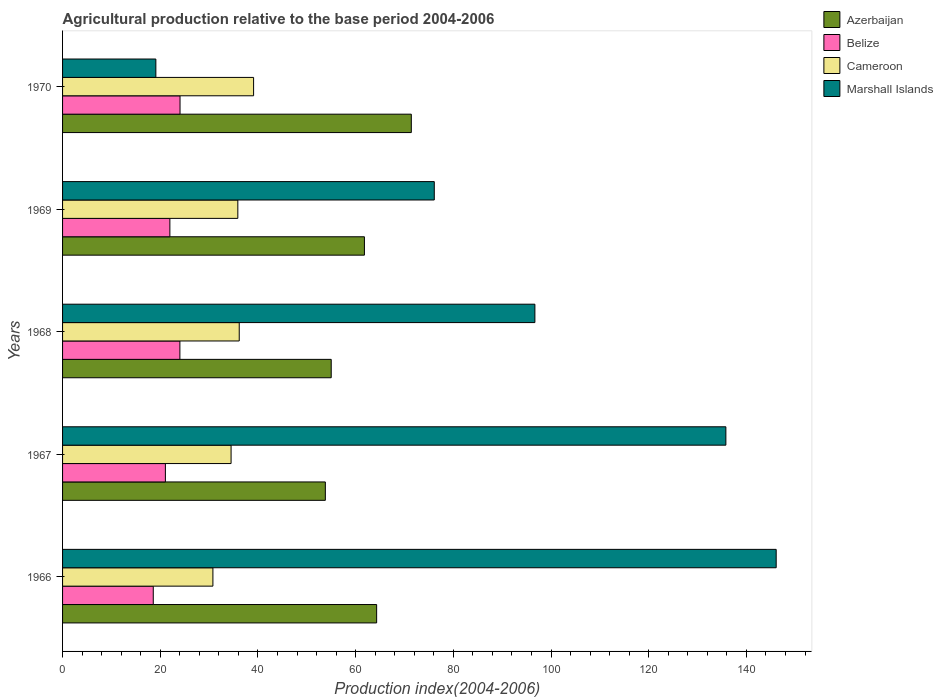How many different coloured bars are there?
Your answer should be compact. 4. Are the number of bars per tick equal to the number of legend labels?
Your answer should be compact. Yes. Are the number of bars on each tick of the Y-axis equal?
Offer a terse response. Yes. What is the label of the 2nd group of bars from the top?
Provide a short and direct response. 1969. What is the agricultural production index in Belize in 1966?
Provide a short and direct response. 18.57. Across all years, what is the maximum agricultural production index in Cameroon?
Keep it short and to the point. 39.11. Across all years, what is the minimum agricultural production index in Azerbaijan?
Offer a terse response. 53.8. In which year was the agricultural production index in Belize maximum?
Your answer should be compact. 1970. In which year was the agricultural production index in Cameroon minimum?
Offer a terse response. 1966. What is the total agricultural production index in Belize in the graph?
Ensure brevity in your answer.  109.66. What is the difference between the agricultural production index in Marshall Islands in 1968 and that in 1969?
Ensure brevity in your answer.  20.6. What is the difference between the agricultural production index in Cameroon in 1969 and the agricultural production index in Marshall Islands in 1968?
Make the answer very short. -60.82. What is the average agricultural production index in Cameroon per year?
Your response must be concise. 35.29. In the year 1967, what is the difference between the agricultural production index in Azerbaijan and agricultural production index in Cameroon?
Keep it short and to the point. 19.3. What is the ratio of the agricultural production index in Cameroon in 1967 to that in 1969?
Ensure brevity in your answer.  0.96. What is the difference between the highest and the second highest agricultural production index in Cameroon?
Offer a very short reply. 2.94. What is the difference between the highest and the lowest agricultural production index in Cameroon?
Provide a succinct answer. 8.33. Is it the case that in every year, the sum of the agricultural production index in Azerbaijan and agricultural production index in Marshall Islands is greater than the sum of agricultural production index in Cameroon and agricultural production index in Belize?
Make the answer very short. Yes. What does the 2nd bar from the top in 1968 represents?
Keep it short and to the point. Cameroon. What does the 4th bar from the bottom in 1966 represents?
Give a very brief answer. Marshall Islands. How many years are there in the graph?
Your response must be concise. 5. What is the difference between two consecutive major ticks on the X-axis?
Your response must be concise. 20. Are the values on the major ticks of X-axis written in scientific E-notation?
Keep it short and to the point. No. How are the legend labels stacked?
Offer a very short reply. Vertical. What is the title of the graph?
Offer a terse response. Agricultural production relative to the base period 2004-2006. What is the label or title of the X-axis?
Provide a short and direct response. Production index(2004-2006). What is the label or title of the Y-axis?
Make the answer very short. Years. What is the Production index(2004-2006) of Azerbaijan in 1966?
Your answer should be very brief. 64.3. What is the Production index(2004-2006) in Belize in 1966?
Your answer should be compact. 18.57. What is the Production index(2004-2006) in Cameroon in 1966?
Your answer should be compact. 30.78. What is the Production index(2004-2006) of Marshall Islands in 1966?
Make the answer very short. 146.1. What is the Production index(2004-2006) of Azerbaijan in 1967?
Keep it short and to the point. 53.8. What is the Production index(2004-2006) of Belize in 1967?
Your answer should be compact. 21.05. What is the Production index(2004-2006) of Cameroon in 1967?
Your answer should be compact. 34.5. What is the Production index(2004-2006) in Marshall Islands in 1967?
Give a very brief answer. 135.8. What is the Production index(2004-2006) in Belize in 1968?
Your answer should be very brief. 24.02. What is the Production index(2004-2006) in Cameroon in 1968?
Offer a very short reply. 36.17. What is the Production index(2004-2006) of Marshall Islands in 1968?
Give a very brief answer. 96.7. What is the Production index(2004-2006) in Azerbaijan in 1969?
Offer a terse response. 61.8. What is the Production index(2004-2006) in Belize in 1969?
Give a very brief answer. 21.97. What is the Production index(2004-2006) of Cameroon in 1969?
Keep it short and to the point. 35.88. What is the Production index(2004-2006) in Marshall Islands in 1969?
Make the answer very short. 76.1. What is the Production index(2004-2006) of Azerbaijan in 1970?
Provide a succinct answer. 71.4. What is the Production index(2004-2006) in Belize in 1970?
Your answer should be compact. 24.05. What is the Production index(2004-2006) of Cameroon in 1970?
Provide a short and direct response. 39.11. What is the Production index(2004-2006) of Marshall Islands in 1970?
Offer a very short reply. 19.1. Across all years, what is the maximum Production index(2004-2006) in Azerbaijan?
Ensure brevity in your answer.  71.4. Across all years, what is the maximum Production index(2004-2006) in Belize?
Provide a succinct answer. 24.05. Across all years, what is the maximum Production index(2004-2006) in Cameroon?
Keep it short and to the point. 39.11. Across all years, what is the maximum Production index(2004-2006) of Marshall Islands?
Keep it short and to the point. 146.1. Across all years, what is the minimum Production index(2004-2006) of Azerbaijan?
Offer a very short reply. 53.8. Across all years, what is the minimum Production index(2004-2006) in Belize?
Make the answer very short. 18.57. Across all years, what is the minimum Production index(2004-2006) in Cameroon?
Provide a succinct answer. 30.78. What is the total Production index(2004-2006) of Azerbaijan in the graph?
Your answer should be very brief. 306.3. What is the total Production index(2004-2006) of Belize in the graph?
Keep it short and to the point. 109.66. What is the total Production index(2004-2006) of Cameroon in the graph?
Offer a very short reply. 176.44. What is the total Production index(2004-2006) of Marshall Islands in the graph?
Make the answer very short. 473.8. What is the difference between the Production index(2004-2006) of Belize in 1966 and that in 1967?
Provide a succinct answer. -2.48. What is the difference between the Production index(2004-2006) in Cameroon in 1966 and that in 1967?
Give a very brief answer. -3.72. What is the difference between the Production index(2004-2006) in Azerbaijan in 1966 and that in 1968?
Your response must be concise. 9.3. What is the difference between the Production index(2004-2006) of Belize in 1966 and that in 1968?
Give a very brief answer. -5.45. What is the difference between the Production index(2004-2006) of Cameroon in 1966 and that in 1968?
Offer a terse response. -5.39. What is the difference between the Production index(2004-2006) in Marshall Islands in 1966 and that in 1968?
Provide a short and direct response. 49.4. What is the difference between the Production index(2004-2006) in Azerbaijan in 1966 and that in 1969?
Make the answer very short. 2.5. What is the difference between the Production index(2004-2006) of Marshall Islands in 1966 and that in 1969?
Your answer should be compact. 70. What is the difference between the Production index(2004-2006) of Belize in 1966 and that in 1970?
Ensure brevity in your answer.  -5.48. What is the difference between the Production index(2004-2006) in Cameroon in 1966 and that in 1970?
Offer a very short reply. -8.33. What is the difference between the Production index(2004-2006) in Marshall Islands in 1966 and that in 1970?
Offer a very short reply. 127. What is the difference between the Production index(2004-2006) in Belize in 1967 and that in 1968?
Your response must be concise. -2.97. What is the difference between the Production index(2004-2006) of Cameroon in 1967 and that in 1968?
Offer a terse response. -1.67. What is the difference between the Production index(2004-2006) of Marshall Islands in 1967 and that in 1968?
Ensure brevity in your answer.  39.1. What is the difference between the Production index(2004-2006) in Azerbaijan in 1967 and that in 1969?
Your response must be concise. -8. What is the difference between the Production index(2004-2006) in Belize in 1967 and that in 1969?
Ensure brevity in your answer.  -0.92. What is the difference between the Production index(2004-2006) of Cameroon in 1967 and that in 1969?
Your answer should be compact. -1.38. What is the difference between the Production index(2004-2006) of Marshall Islands in 1967 and that in 1969?
Your answer should be compact. 59.7. What is the difference between the Production index(2004-2006) of Azerbaijan in 1967 and that in 1970?
Make the answer very short. -17.6. What is the difference between the Production index(2004-2006) in Cameroon in 1967 and that in 1970?
Provide a succinct answer. -4.61. What is the difference between the Production index(2004-2006) of Marshall Islands in 1967 and that in 1970?
Make the answer very short. 116.7. What is the difference between the Production index(2004-2006) of Belize in 1968 and that in 1969?
Your response must be concise. 2.05. What is the difference between the Production index(2004-2006) of Cameroon in 1968 and that in 1969?
Provide a short and direct response. 0.29. What is the difference between the Production index(2004-2006) of Marshall Islands in 1968 and that in 1969?
Provide a short and direct response. 20.6. What is the difference between the Production index(2004-2006) of Azerbaijan in 1968 and that in 1970?
Offer a very short reply. -16.4. What is the difference between the Production index(2004-2006) of Belize in 1968 and that in 1970?
Your answer should be very brief. -0.03. What is the difference between the Production index(2004-2006) of Cameroon in 1968 and that in 1970?
Offer a very short reply. -2.94. What is the difference between the Production index(2004-2006) of Marshall Islands in 1968 and that in 1970?
Give a very brief answer. 77.6. What is the difference between the Production index(2004-2006) in Azerbaijan in 1969 and that in 1970?
Your answer should be compact. -9.6. What is the difference between the Production index(2004-2006) of Belize in 1969 and that in 1970?
Keep it short and to the point. -2.08. What is the difference between the Production index(2004-2006) of Cameroon in 1969 and that in 1970?
Your answer should be compact. -3.23. What is the difference between the Production index(2004-2006) in Azerbaijan in 1966 and the Production index(2004-2006) in Belize in 1967?
Your answer should be very brief. 43.25. What is the difference between the Production index(2004-2006) of Azerbaijan in 1966 and the Production index(2004-2006) of Cameroon in 1967?
Make the answer very short. 29.8. What is the difference between the Production index(2004-2006) of Azerbaijan in 1966 and the Production index(2004-2006) of Marshall Islands in 1967?
Provide a succinct answer. -71.5. What is the difference between the Production index(2004-2006) in Belize in 1966 and the Production index(2004-2006) in Cameroon in 1967?
Keep it short and to the point. -15.93. What is the difference between the Production index(2004-2006) in Belize in 1966 and the Production index(2004-2006) in Marshall Islands in 1967?
Give a very brief answer. -117.23. What is the difference between the Production index(2004-2006) of Cameroon in 1966 and the Production index(2004-2006) of Marshall Islands in 1967?
Your answer should be compact. -105.02. What is the difference between the Production index(2004-2006) in Azerbaijan in 1966 and the Production index(2004-2006) in Belize in 1968?
Give a very brief answer. 40.28. What is the difference between the Production index(2004-2006) in Azerbaijan in 1966 and the Production index(2004-2006) in Cameroon in 1968?
Your response must be concise. 28.13. What is the difference between the Production index(2004-2006) of Azerbaijan in 1966 and the Production index(2004-2006) of Marshall Islands in 1968?
Make the answer very short. -32.4. What is the difference between the Production index(2004-2006) of Belize in 1966 and the Production index(2004-2006) of Cameroon in 1968?
Your answer should be compact. -17.6. What is the difference between the Production index(2004-2006) of Belize in 1966 and the Production index(2004-2006) of Marshall Islands in 1968?
Keep it short and to the point. -78.13. What is the difference between the Production index(2004-2006) in Cameroon in 1966 and the Production index(2004-2006) in Marshall Islands in 1968?
Offer a terse response. -65.92. What is the difference between the Production index(2004-2006) of Azerbaijan in 1966 and the Production index(2004-2006) of Belize in 1969?
Offer a terse response. 42.33. What is the difference between the Production index(2004-2006) of Azerbaijan in 1966 and the Production index(2004-2006) of Cameroon in 1969?
Make the answer very short. 28.42. What is the difference between the Production index(2004-2006) in Azerbaijan in 1966 and the Production index(2004-2006) in Marshall Islands in 1969?
Keep it short and to the point. -11.8. What is the difference between the Production index(2004-2006) of Belize in 1966 and the Production index(2004-2006) of Cameroon in 1969?
Your answer should be compact. -17.31. What is the difference between the Production index(2004-2006) in Belize in 1966 and the Production index(2004-2006) in Marshall Islands in 1969?
Offer a terse response. -57.53. What is the difference between the Production index(2004-2006) of Cameroon in 1966 and the Production index(2004-2006) of Marshall Islands in 1969?
Give a very brief answer. -45.32. What is the difference between the Production index(2004-2006) in Azerbaijan in 1966 and the Production index(2004-2006) in Belize in 1970?
Provide a short and direct response. 40.25. What is the difference between the Production index(2004-2006) of Azerbaijan in 1966 and the Production index(2004-2006) of Cameroon in 1970?
Give a very brief answer. 25.19. What is the difference between the Production index(2004-2006) in Azerbaijan in 1966 and the Production index(2004-2006) in Marshall Islands in 1970?
Ensure brevity in your answer.  45.2. What is the difference between the Production index(2004-2006) in Belize in 1966 and the Production index(2004-2006) in Cameroon in 1970?
Keep it short and to the point. -20.54. What is the difference between the Production index(2004-2006) of Belize in 1966 and the Production index(2004-2006) of Marshall Islands in 1970?
Give a very brief answer. -0.53. What is the difference between the Production index(2004-2006) in Cameroon in 1966 and the Production index(2004-2006) in Marshall Islands in 1970?
Ensure brevity in your answer.  11.68. What is the difference between the Production index(2004-2006) in Azerbaijan in 1967 and the Production index(2004-2006) in Belize in 1968?
Ensure brevity in your answer.  29.78. What is the difference between the Production index(2004-2006) of Azerbaijan in 1967 and the Production index(2004-2006) of Cameroon in 1968?
Your answer should be compact. 17.63. What is the difference between the Production index(2004-2006) in Azerbaijan in 1967 and the Production index(2004-2006) in Marshall Islands in 1968?
Your response must be concise. -42.9. What is the difference between the Production index(2004-2006) of Belize in 1967 and the Production index(2004-2006) of Cameroon in 1968?
Provide a succinct answer. -15.12. What is the difference between the Production index(2004-2006) in Belize in 1967 and the Production index(2004-2006) in Marshall Islands in 1968?
Provide a succinct answer. -75.65. What is the difference between the Production index(2004-2006) in Cameroon in 1967 and the Production index(2004-2006) in Marshall Islands in 1968?
Offer a very short reply. -62.2. What is the difference between the Production index(2004-2006) of Azerbaijan in 1967 and the Production index(2004-2006) of Belize in 1969?
Your answer should be compact. 31.83. What is the difference between the Production index(2004-2006) in Azerbaijan in 1967 and the Production index(2004-2006) in Cameroon in 1969?
Make the answer very short. 17.92. What is the difference between the Production index(2004-2006) in Azerbaijan in 1967 and the Production index(2004-2006) in Marshall Islands in 1969?
Offer a very short reply. -22.3. What is the difference between the Production index(2004-2006) of Belize in 1967 and the Production index(2004-2006) of Cameroon in 1969?
Your response must be concise. -14.83. What is the difference between the Production index(2004-2006) in Belize in 1967 and the Production index(2004-2006) in Marshall Islands in 1969?
Your answer should be very brief. -55.05. What is the difference between the Production index(2004-2006) of Cameroon in 1967 and the Production index(2004-2006) of Marshall Islands in 1969?
Provide a short and direct response. -41.6. What is the difference between the Production index(2004-2006) of Azerbaijan in 1967 and the Production index(2004-2006) of Belize in 1970?
Your answer should be compact. 29.75. What is the difference between the Production index(2004-2006) in Azerbaijan in 1967 and the Production index(2004-2006) in Cameroon in 1970?
Provide a short and direct response. 14.69. What is the difference between the Production index(2004-2006) of Azerbaijan in 1967 and the Production index(2004-2006) of Marshall Islands in 1970?
Provide a succinct answer. 34.7. What is the difference between the Production index(2004-2006) in Belize in 1967 and the Production index(2004-2006) in Cameroon in 1970?
Offer a very short reply. -18.06. What is the difference between the Production index(2004-2006) in Belize in 1967 and the Production index(2004-2006) in Marshall Islands in 1970?
Provide a succinct answer. 1.95. What is the difference between the Production index(2004-2006) in Cameroon in 1967 and the Production index(2004-2006) in Marshall Islands in 1970?
Keep it short and to the point. 15.4. What is the difference between the Production index(2004-2006) of Azerbaijan in 1968 and the Production index(2004-2006) of Belize in 1969?
Make the answer very short. 33.03. What is the difference between the Production index(2004-2006) in Azerbaijan in 1968 and the Production index(2004-2006) in Cameroon in 1969?
Provide a succinct answer. 19.12. What is the difference between the Production index(2004-2006) of Azerbaijan in 1968 and the Production index(2004-2006) of Marshall Islands in 1969?
Provide a short and direct response. -21.1. What is the difference between the Production index(2004-2006) in Belize in 1968 and the Production index(2004-2006) in Cameroon in 1969?
Ensure brevity in your answer.  -11.86. What is the difference between the Production index(2004-2006) in Belize in 1968 and the Production index(2004-2006) in Marshall Islands in 1969?
Ensure brevity in your answer.  -52.08. What is the difference between the Production index(2004-2006) of Cameroon in 1968 and the Production index(2004-2006) of Marshall Islands in 1969?
Your answer should be compact. -39.93. What is the difference between the Production index(2004-2006) in Azerbaijan in 1968 and the Production index(2004-2006) in Belize in 1970?
Make the answer very short. 30.95. What is the difference between the Production index(2004-2006) of Azerbaijan in 1968 and the Production index(2004-2006) of Cameroon in 1970?
Your answer should be compact. 15.89. What is the difference between the Production index(2004-2006) in Azerbaijan in 1968 and the Production index(2004-2006) in Marshall Islands in 1970?
Keep it short and to the point. 35.9. What is the difference between the Production index(2004-2006) of Belize in 1968 and the Production index(2004-2006) of Cameroon in 1970?
Offer a very short reply. -15.09. What is the difference between the Production index(2004-2006) in Belize in 1968 and the Production index(2004-2006) in Marshall Islands in 1970?
Provide a succinct answer. 4.92. What is the difference between the Production index(2004-2006) in Cameroon in 1968 and the Production index(2004-2006) in Marshall Islands in 1970?
Offer a terse response. 17.07. What is the difference between the Production index(2004-2006) of Azerbaijan in 1969 and the Production index(2004-2006) of Belize in 1970?
Ensure brevity in your answer.  37.75. What is the difference between the Production index(2004-2006) in Azerbaijan in 1969 and the Production index(2004-2006) in Cameroon in 1970?
Offer a very short reply. 22.69. What is the difference between the Production index(2004-2006) of Azerbaijan in 1969 and the Production index(2004-2006) of Marshall Islands in 1970?
Keep it short and to the point. 42.7. What is the difference between the Production index(2004-2006) in Belize in 1969 and the Production index(2004-2006) in Cameroon in 1970?
Offer a very short reply. -17.14. What is the difference between the Production index(2004-2006) in Belize in 1969 and the Production index(2004-2006) in Marshall Islands in 1970?
Keep it short and to the point. 2.87. What is the difference between the Production index(2004-2006) of Cameroon in 1969 and the Production index(2004-2006) of Marshall Islands in 1970?
Offer a terse response. 16.78. What is the average Production index(2004-2006) of Azerbaijan per year?
Offer a terse response. 61.26. What is the average Production index(2004-2006) of Belize per year?
Your answer should be compact. 21.93. What is the average Production index(2004-2006) in Cameroon per year?
Give a very brief answer. 35.29. What is the average Production index(2004-2006) in Marshall Islands per year?
Your answer should be compact. 94.76. In the year 1966, what is the difference between the Production index(2004-2006) in Azerbaijan and Production index(2004-2006) in Belize?
Provide a succinct answer. 45.73. In the year 1966, what is the difference between the Production index(2004-2006) of Azerbaijan and Production index(2004-2006) of Cameroon?
Offer a terse response. 33.52. In the year 1966, what is the difference between the Production index(2004-2006) in Azerbaijan and Production index(2004-2006) in Marshall Islands?
Provide a short and direct response. -81.8. In the year 1966, what is the difference between the Production index(2004-2006) of Belize and Production index(2004-2006) of Cameroon?
Give a very brief answer. -12.21. In the year 1966, what is the difference between the Production index(2004-2006) in Belize and Production index(2004-2006) in Marshall Islands?
Ensure brevity in your answer.  -127.53. In the year 1966, what is the difference between the Production index(2004-2006) in Cameroon and Production index(2004-2006) in Marshall Islands?
Your response must be concise. -115.32. In the year 1967, what is the difference between the Production index(2004-2006) of Azerbaijan and Production index(2004-2006) of Belize?
Make the answer very short. 32.75. In the year 1967, what is the difference between the Production index(2004-2006) in Azerbaijan and Production index(2004-2006) in Cameroon?
Provide a succinct answer. 19.3. In the year 1967, what is the difference between the Production index(2004-2006) in Azerbaijan and Production index(2004-2006) in Marshall Islands?
Give a very brief answer. -82. In the year 1967, what is the difference between the Production index(2004-2006) of Belize and Production index(2004-2006) of Cameroon?
Ensure brevity in your answer.  -13.45. In the year 1967, what is the difference between the Production index(2004-2006) in Belize and Production index(2004-2006) in Marshall Islands?
Offer a terse response. -114.75. In the year 1967, what is the difference between the Production index(2004-2006) of Cameroon and Production index(2004-2006) of Marshall Islands?
Give a very brief answer. -101.3. In the year 1968, what is the difference between the Production index(2004-2006) in Azerbaijan and Production index(2004-2006) in Belize?
Your response must be concise. 30.98. In the year 1968, what is the difference between the Production index(2004-2006) in Azerbaijan and Production index(2004-2006) in Cameroon?
Provide a short and direct response. 18.83. In the year 1968, what is the difference between the Production index(2004-2006) in Azerbaijan and Production index(2004-2006) in Marshall Islands?
Give a very brief answer. -41.7. In the year 1968, what is the difference between the Production index(2004-2006) in Belize and Production index(2004-2006) in Cameroon?
Keep it short and to the point. -12.15. In the year 1968, what is the difference between the Production index(2004-2006) in Belize and Production index(2004-2006) in Marshall Islands?
Offer a very short reply. -72.68. In the year 1968, what is the difference between the Production index(2004-2006) of Cameroon and Production index(2004-2006) of Marshall Islands?
Your answer should be compact. -60.53. In the year 1969, what is the difference between the Production index(2004-2006) in Azerbaijan and Production index(2004-2006) in Belize?
Offer a terse response. 39.83. In the year 1969, what is the difference between the Production index(2004-2006) in Azerbaijan and Production index(2004-2006) in Cameroon?
Offer a terse response. 25.92. In the year 1969, what is the difference between the Production index(2004-2006) of Azerbaijan and Production index(2004-2006) of Marshall Islands?
Provide a short and direct response. -14.3. In the year 1969, what is the difference between the Production index(2004-2006) of Belize and Production index(2004-2006) of Cameroon?
Your answer should be compact. -13.91. In the year 1969, what is the difference between the Production index(2004-2006) of Belize and Production index(2004-2006) of Marshall Islands?
Provide a succinct answer. -54.13. In the year 1969, what is the difference between the Production index(2004-2006) in Cameroon and Production index(2004-2006) in Marshall Islands?
Make the answer very short. -40.22. In the year 1970, what is the difference between the Production index(2004-2006) in Azerbaijan and Production index(2004-2006) in Belize?
Your answer should be compact. 47.35. In the year 1970, what is the difference between the Production index(2004-2006) in Azerbaijan and Production index(2004-2006) in Cameroon?
Provide a succinct answer. 32.29. In the year 1970, what is the difference between the Production index(2004-2006) in Azerbaijan and Production index(2004-2006) in Marshall Islands?
Give a very brief answer. 52.3. In the year 1970, what is the difference between the Production index(2004-2006) in Belize and Production index(2004-2006) in Cameroon?
Provide a succinct answer. -15.06. In the year 1970, what is the difference between the Production index(2004-2006) of Belize and Production index(2004-2006) of Marshall Islands?
Your answer should be compact. 4.95. In the year 1970, what is the difference between the Production index(2004-2006) in Cameroon and Production index(2004-2006) in Marshall Islands?
Offer a terse response. 20.01. What is the ratio of the Production index(2004-2006) of Azerbaijan in 1966 to that in 1967?
Provide a succinct answer. 1.2. What is the ratio of the Production index(2004-2006) in Belize in 1966 to that in 1967?
Your response must be concise. 0.88. What is the ratio of the Production index(2004-2006) of Cameroon in 1966 to that in 1967?
Your response must be concise. 0.89. What is the ratio of the Production index(2004-2006) in Marshall Islands in 1966 to that in 1967?
Ensure brevity in your answer.  1.08. What is the ratio of the Production index(2004-2006) of Azerbaijan in 1966 to that in 1968?
Provide a short and direct response. 1.17. What is the ratio of the Production index(2004-2006) of Belize in 1966 to that in 1968?
Give a very brief answer. 0.77. What is the ratio of the Production index(2004-2006) in Cameroon in 1966 to that in 1968?
Ensure brevity in your answer.  0.85. What is the ratio of the Production index(2004-2006) of Marshall Islands in 1966 to that in 1968?
Your answer should be compact. 1.51. What is the ratio of the Production index(2004-2006) of Azerbaijan in 1966 to that in 1969?
Your answer should be compact. 1.04. What is the ratio of the Production index(2004-2006) in Belize in 1966 to that in 1969?
Provide a succinct answer. 0.85. What is the ratio of the Production index(2004-2006) of Cameroon in 1966 to that in 1969?
Your answer should be very brief. 0.86. What is the ratio of the Production index(2004-2006) in Marshall Islands in 1966 to that in 1969?
Offer a terse response. 1.92. What is the ratio of the Production index(2004-2006) in Azerbaijan in 1966 to that in 1970?
Give a very brief answer. 0.9. What is the ratio of the Production index(2004-2006) of Belize in 1966 to that in 1970?
Offer a terse response. 0.77. What is the ratio of the Production index(2004-2006) of Cameroon in 1966 to that in 1970?
Provide a short and direct response. 0.79. What is the ratio of the Production index(2004-2006) in Marshall Islands in 1966 to that in 1970?
Keep it short and to the point. 7.65. What is the ratio of the Production index(2004-2006) in Azerbaijan in 1967 to that in 1968?
Provide a succinct answer. 0.98. What is the ratio of the Production index(2004-2006) of Belize in 1967 to that in 1968?
Provide a short and direct response. 0.88. What is the ratio of the Production index(2004-2006) in Cameroon in 1967 to that in 1968?
Make the answer very short. 0.95. What is the ratio of the Production index(2004-2006) in Marshall Islands in 1967 to that in 1968?
Your response must be concise. 1.4. What is the ratio of the Production index(2004-2006) in Azerbaijan in 1967 to that in 1969?
Offer a terse response. 0.87. What is the ratio of the Production index(2004-2006) of Belize in 1967 to that in 1969?
Your response must be concise. 0.96. What is the ratio of the Production index(2004-2006) of Cameroon in 1967 to that in 1969?
Provide a succinct answer. 0.96. What is the ratio of the Production index(2004-2006) in Marshall Islands in 1967 to that in 1969?
Your response must be concise. 1.78. What is the ratio of the Production index(2004-2006) of Azerbaijan in 1967 to that in 1970?
Your answer should be very brief. 0.75. What is the ratio of the Production index(2004-2006) of Belize in 1967 to that in 1970?
Keep it short and to the point. 0.88. What is the ratio of the Production index(2004-2006) in Cameroon in 1967 to that in 1970?
Your answer should be very brief. 0.88. What is the ratio of the Production index(2004-2006) in Marshall Islands in 1967 to that in 1970?
Your answer should be very brief. 7.11. What is the ratio of the Production index(2004-2006) in Azerbaijan in 1968 to that in 1969?
Offer a terse response. 0.89. What is the ratio of the Production index(2004-2006) in Belize in 1968 to that in 1969?
Ensure brevity in your answer.  1.09. What is the ratio of the Production index(2004-2006) in Marshall Islands in 1968 to that in 1969?
Ensure brevity in your answer.  1.27. What is the ratio of the Production index(2004-2006) of Azerbaijan in 1968 to that in 1970?
Make the answer very short. 0.77. What is the ratio of the Production index(2004-2006) in Belize in 1968 to that in 1970?
Offer a very short reply. 1. What is the ratio of the Production index(2004-2006) in Cameroon in 1968 to that in 1970?
Provide a succinct answer. 0.92. What is the ratio of the Production index(2004-2006) in Marshall Islands in 1968 to that in 1970?
Make the answer very short. 5.06. What is the ratio of the Production index(2004-2006) of Azerbaijan in 1969 to that in 1970?
Your answer should be compact. 0.87. What is the ratio of the Production index(2004-2006) of Belize in 1969 to that in 1970?
Your answer should be very brief. 0.91. What is the ratio of the Production index(2004-2006) in Cameroon in 1969 to that in 1970?
Provide a short and direct response. 0.92. What is the ratio of the Production index(2004-2006) of Marshall Islands in 1969 to that in 1970?
Your response must be concise. 3.98. What is the difference between the highest and the second highest Production index(2004-2006) in Cameroon?
Make the answer very short. 2.94. What is the difference between the highest and the second highest Production index(2004-2006) in Marshall Islands?
Your response must be concise. 10.3. What is the difference between the highest and the lowest Production index(2004-2006) of Azerbaijan?
Offer a terse response. 17.6. What is the difference between the highest and the lowest Production index(2004-2006) of Belize?
Offer a terse response. 5.48. What is the difference between the highest and the lowest Production index(2004-2006) of Cameroon?
Your response must be concise. 8.33. What is the difference between the highest and the lowest Production index(2004-2006) in Marshall Islands?
Give a very brief answer. 127. 